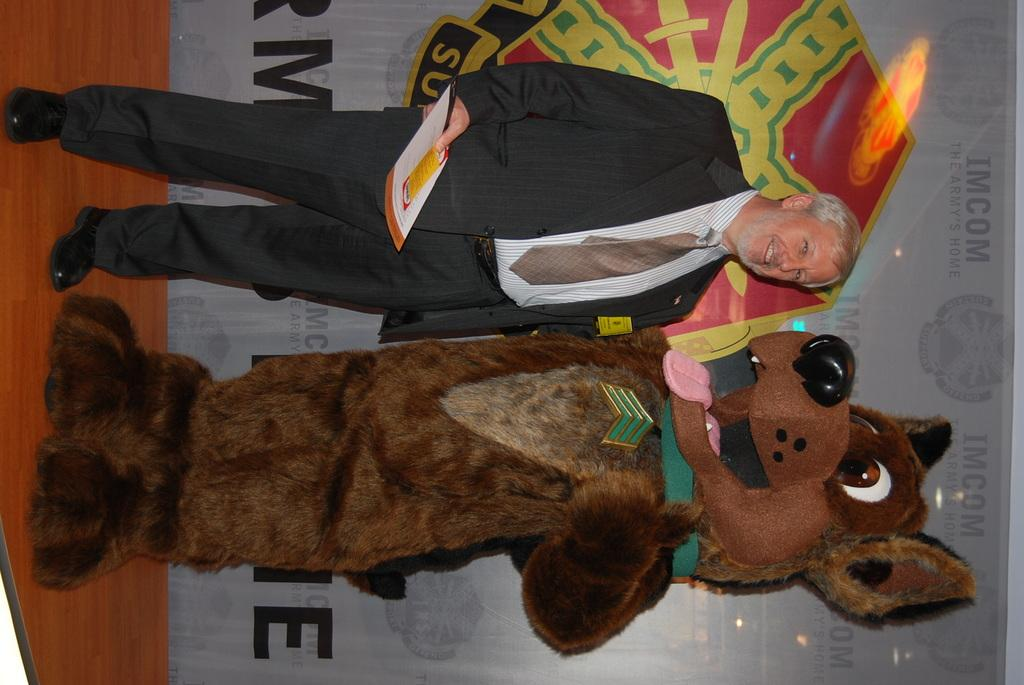What is the expression of the person in the image? The person in the image has a smile. What is the person with a costume doing in the image? The person with a costume is standing in the image. What can be seen in the background of the image? There is a banner in the background of the image. How many clouds are visible in the image? There are no clouds visible in the image. What idea does the person with a costume have in the image? The image does not provide information about the person's ideas or thoughts. 